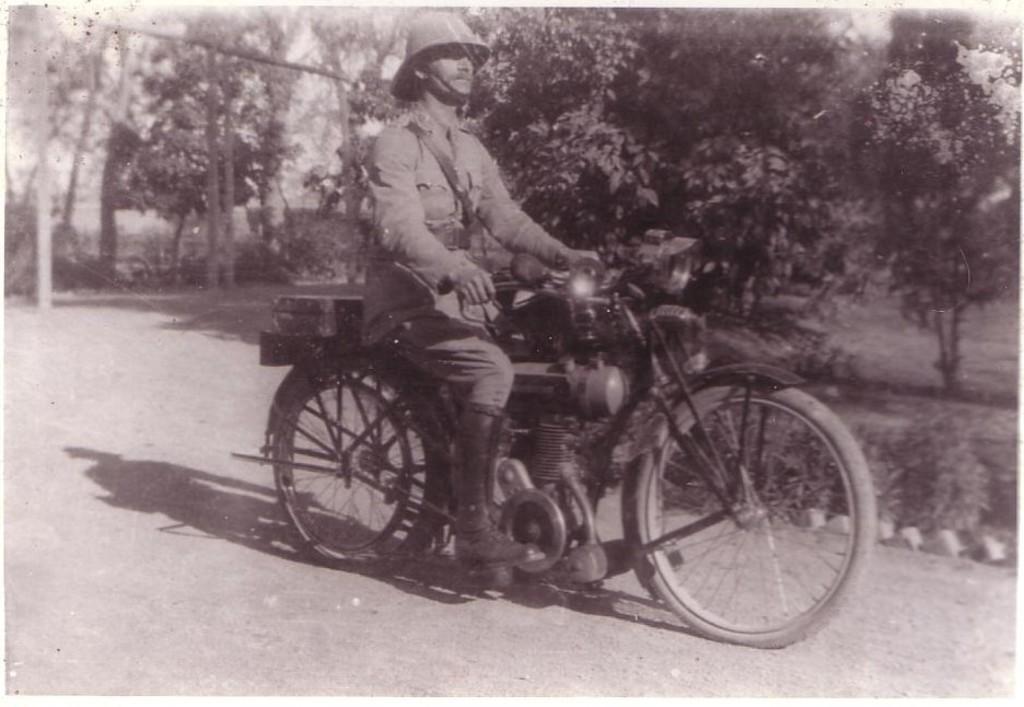Please provide a concise description of this image. In this image, a man is riding a motorbike. At the background, we can see a trees. A man is wearing a helmet and boots. 